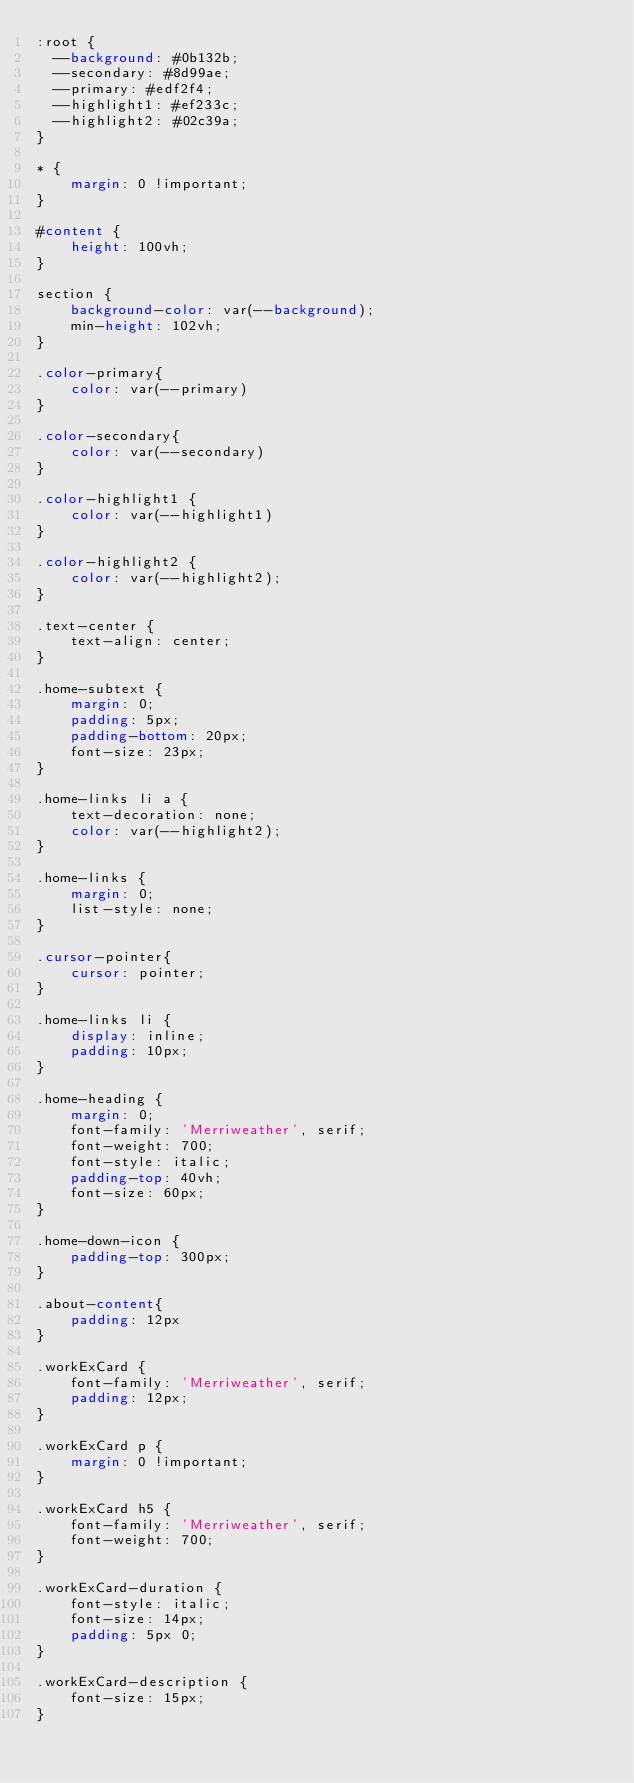<code> <loc_0><loc_0><loc_500><loc_500><_CSS_>:root {
  --background: #0b132b;
  --secondary: #8d99ae;
  --primary: #edf2f4;
  --highlight1: #ef233c;
  --highlight2: #02c39a;
}

* {
    margin: 0 !important;
}

#content {
    height: 100vh;
}

section {    
    background-color: var(--background);
    min-height: 102vh;
}

.color-primary{
    color: var(--primary)
}

.color-secondary{
    color: var(--secondary)
}

.color-highlight1 {
    color: var(--highlight1)
}

.color-highlight2 {
    color: var(--highlight2);
}

.text-center {
    text-align: center;
}

.home-subtext {
    margin: 0;
    padding: 5px;
    padding-bottom: 20px;
    font-size: 23px;
}

.home-links li a {
    text-decoration: none;
    color: var(--highlight2);
}

.home-links {
    margin: 0;
    list-style: none;
}

.cursor-pointer{
    cursor: pointer;
}

.home-links li {
    display: inline;
    padding: 10px;
}

.home-heading {
    margin: 0;
    font-family: 'Merriweather', serif;
    font-weight: 700;
    font-style: italic;
    padding-top: 40vh;
    font-size: 60px;
}

.home-down-icon {
    padding-top: 300px;
}

.about-content{
    padding: 12px
}

.workExCard {
    font-family: 'Merriweather', serif;
    padding: 12px;
}

.workExCard p {
    margin: 0 !important;
}

.workExCard h5 {
    font-family: 'Merriweather', serif;
    font-weight: 700;
}

.workExCard-duration {
    font-style: italic;
    font-size: 14px;
    padding: 5px 0;
}

.workExCard-description {
    font-size: 15px;
}</code> 